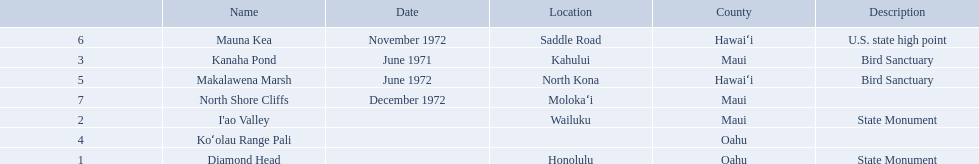What are the different landmark names? Diamond Head, I'ao Valley, Kanaha Pond, Koʻolau Range Pali, Makalawena Marsh, Mauna Kea, North Shore Cliffs. Would you be able to parse every entry in this table? {'header': ['', 'Name', 'Date', 'Location', 'County', 'Description'], 'rows': [['6', 'Mauna Kea', 'November 1972', 'Saddle Road', 'Hawaiʻi', 'U.S. state high point'], ['3', 'Kanaha Pond', 'June 1971', 'Kahului', 'Maui', 'Bird Sanctuary'], ['5', 'Makalawena Marsh', 'June 1972', 'North Kona', 'Hawaiʻi', 'Bird Sanctuary'], ['7', 'North Shore Cliffs', 'December 1972', 'Molokaʻi', 'Maui', ''], ['2', "I'ao Valley", '', 'Wailuku', 'Maui', 'State Monument'], ['4', 'Koʻolau Range Pali', '', '', 'Oahu', ''], ['1', 'Diamond Head', '', 'Honolulu', 'Oahu', 'State Monument']]} Which of these is located in the county hawai`i? Makalawena Marsh, Mauna Kea. Which of these is not mauna kea? Makalawena Marsh. What are the natural landmarks in hawaii(national)? Diamond Head, I'ao Valley, Kanaha Pond, Koʻolau Range Pali, Makalawena Marsh, Mauna Kea, North Shore Cliffs. Of these which is described as a u.s state high point? Mauna Kea. What are all of the landmark names in hawaii? Diamond Head, I'ao Valley, Kanaha Pond, Koʻolau Range Pali, Makalawena Marsh, Mauna Kea, North Shore Cliffs. What are their descriptions? State Monument, State Monument, Bird Sanctuary, , Bird Sanctuary, U.S. state high point, . And which is described as a u.s. state high point? Mauna Kea. 